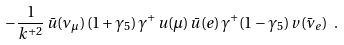Convert formula to latex. <formula><loc_0><loc_0><loc_500><loc_500>- \frac { 1 } { k ^ { + 2 } } \, { \bar { u } } ( \nu _ { \mu } ) \, ( 1 + \gamma _ { 5 } ) \, \gamma ^ { + } \, u ( \mu ) \, { \bar { u } } ( e ) \, \gamma ^ { + } ( 1 - \gamma _ { 5 } ) \, v ( { \bar { \nu } } _ { e } ) \ .</formula> 